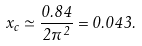<formula> <loc_0><loc_0><loc_500><loc_500>x _ { c } \simeq \frac { 0 . 8 4 } { 2 \pi ^ { 2 } } = 0 . 0 4 3 .</formula> 